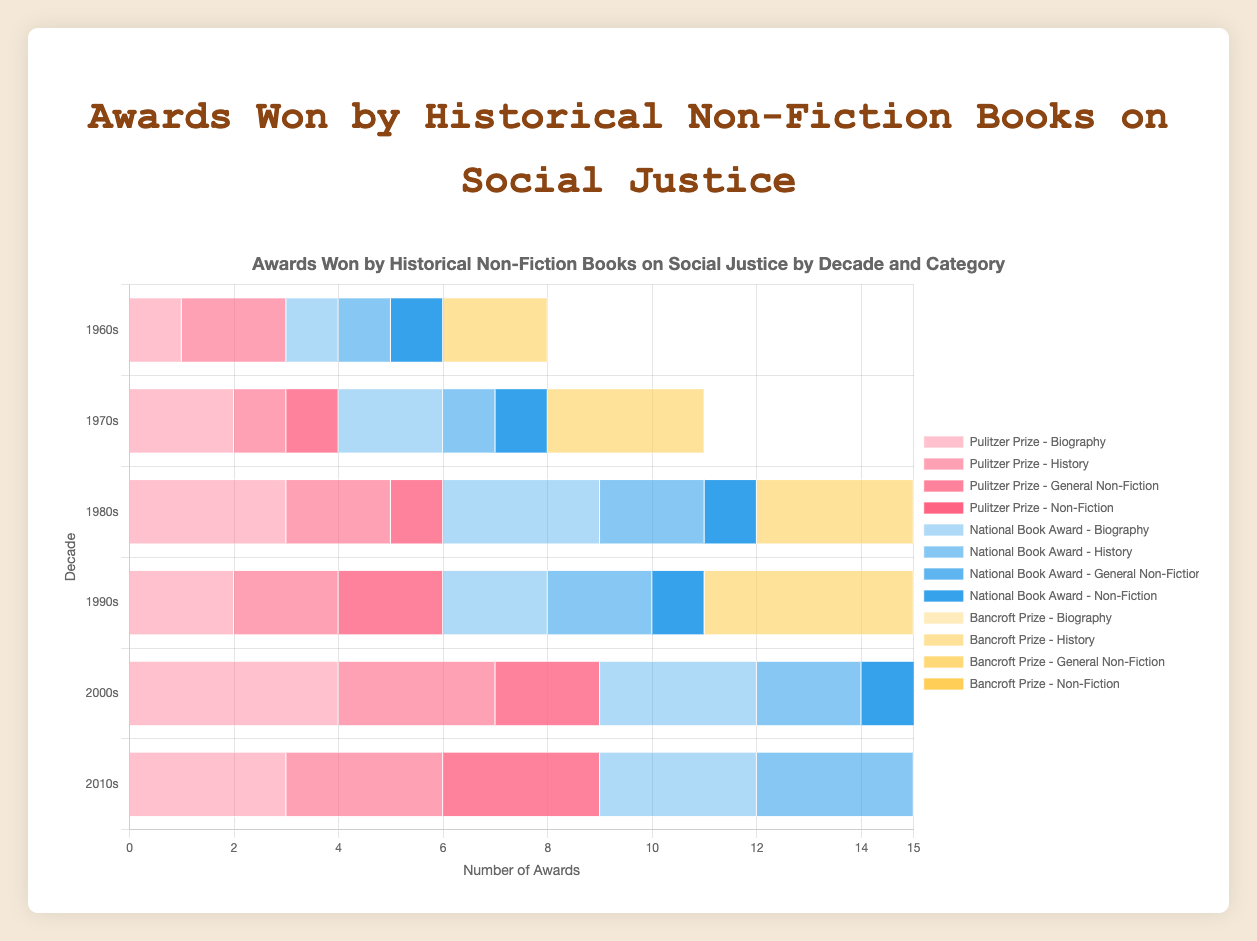How many Pulitzer Prizes were awarded for "History" in the 1980s? Look for the "Pulitzer Prize" bars corresponding to the "1980s" decade and note the count for "History".
Answer: 2 Which decade had the highest total number of awards for "Pulitzer Prize - Biography"? Examine the counts of "Pulitzer Prize - Biography" across all decades and find the highest. The 2000s have the highest with 4 awards.
Answer: 2000s Which decade saw the most "Bancroft Prize" awards for "History"? Compare the "Bancroft Prize" bars for "History" across all decades. The 2010s have the highest with 5 awards.
Answer: 2010s How many total awards were won by historical non-fiction books in the 1960s? Sum all awards across all categories and prizes for the 1960s. (1+2+0+1+1+1+2) = 8
Answer: 8 In which decade was there a tie in the number of "National Book Award - Biography" and "National Book Award - History" awards? Compare the counts of "National Book Award - Biography" and "National Book Award - History" for each decade. The 2010s have equal counts of 3.
Answer: 2010s Was the total number of "Pulitzer Prize - General Non-Fiction" awards greater in the 1990s or the 2010s? Add up the "Pulitzer Prize - General Non-Fiction" awards for 1990s and 2010s, then compare. (1990s: 2 vs 2010s: 3)
Answer: 2010s Which prize has had consistent increments in the "History" category across the decades from 1960s to 2010s? Inspect the values for "History" for each award across decades. Note the pattern of growth. The "Bancroft Prize" for history consistently increases every decade.
Answer: Bancroft Prize Compare the number of "National Book Award - Non-Fiction" awards between the 1960s and 2000s. Locate the counts for "National Book Award - Non-Fiction" in the 1960s and 2000s and compare (1960s: 1 vs 2000s: 2).
Answer: 2000s What is the combined total of "National Book Award - Biography" and "Pulitzer Prize - Biography" in the 1970s? Add the counts of "National Book Award - Biography" and "Pulitzer Prize - Biography" in the 1970s. (2 + 2) = 4
Answer: 4 